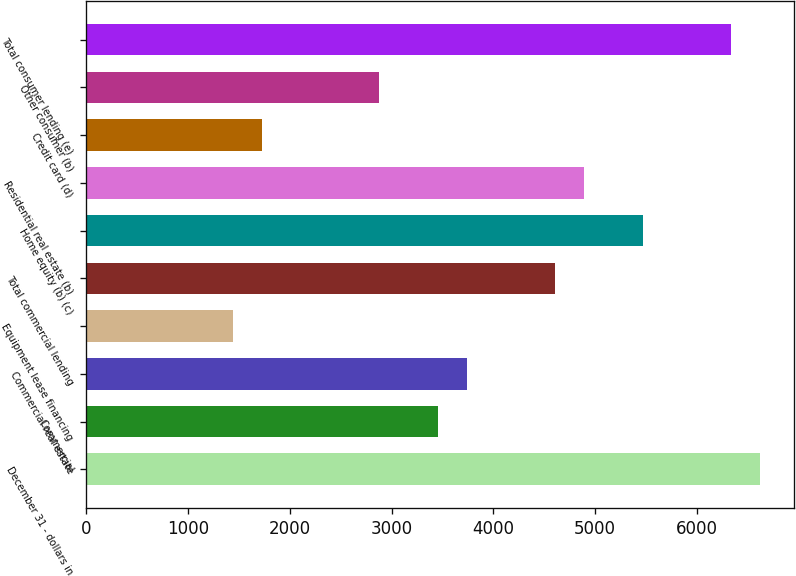Convert chart to OTSL. <chart><loc_0><loc_0><loc_500><loc_500><bar_chart><fcel>December 31 - dollars in<fcel>Commercial<fcel>Commercial real estate<fcel>Equipment lease financing<fcel>Total commercial lending<fcel>Home equity (b) (c)<fcel>Residential real estate (b)<fcel>Credit card (d)<fcel>Other consumer (b)<fcel>Total consumer lending (e)<nl><fcel>6623.48<fcel>3455.92<fcel>3743.88<fcel>1440.2<fcel>4607.76<fcel>5471.64<fcel>4895.72<fcel>1728.16<fcel>2880<fcel>6335.52<nl></chart> 